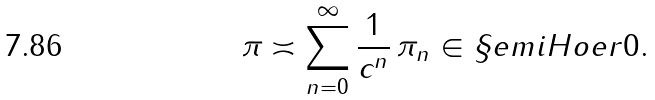<formula> <loc_0><loc_0><loc_500><loc_500>\pi \asymp \sum _ { n = 0 } ^ { \infty } \frac { 1 } { c ^ { n } } \, \pi _ { n } \in \S e m i H o e r { 0 } .</formula> 